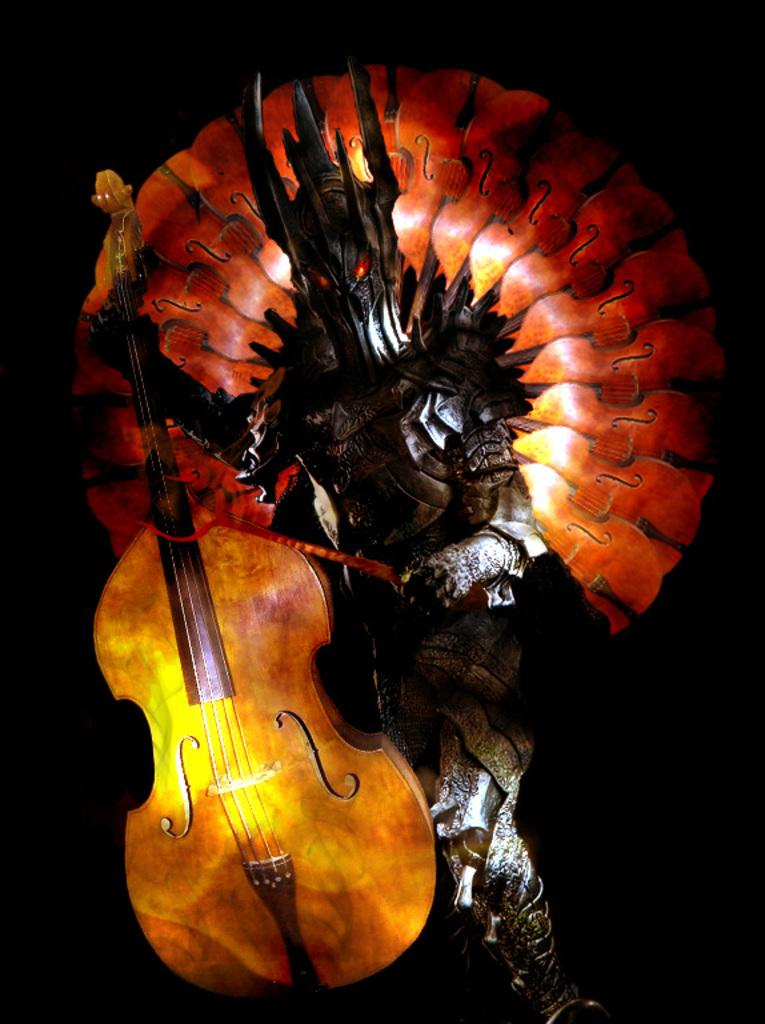What musical instrument is present in the image? There is a guitar in the image. What type of artwork can be seen in the image? There is a sculpture in the image. What type of jail is depicted in the image? There is no jail present in the image; it features a guitar and a sculpture. How does the fog affect the visibility of the sculpture in the image? There is no fog present in the image, so its effect on the visibility of the sculpture cannot be determined. 